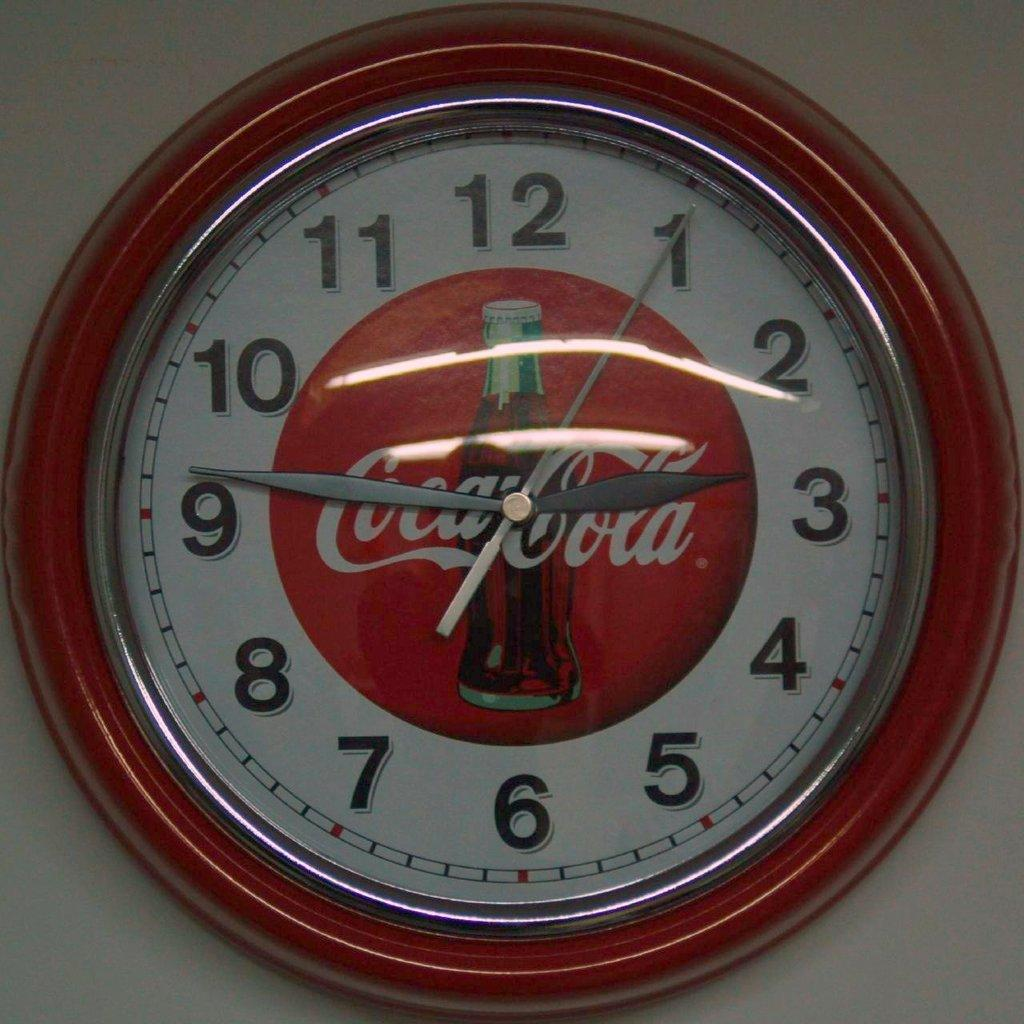<image>
Present a compact description of the photo's key features. A red clock says Coca-Cola and has a coke bottle. 